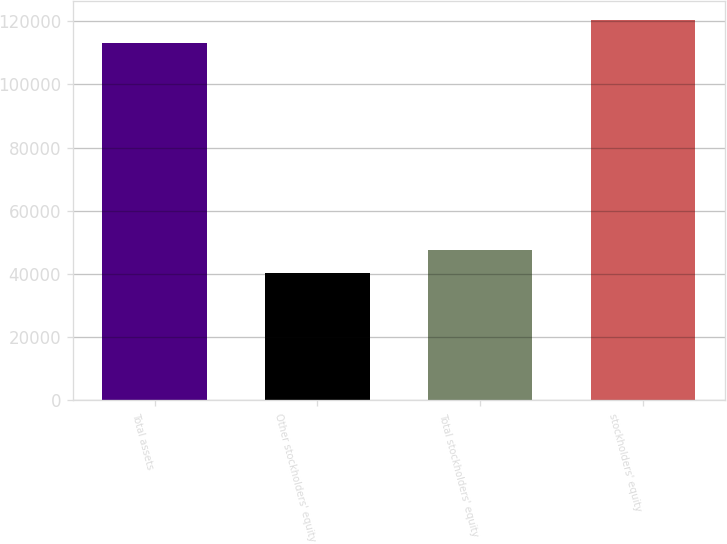Convert chart. <chart><loc_0><loc_0><loc_500><loc_500><bar_chart><fcel>Total assets<fcel>Other stockholders' equity<fcel>Total stockholders' equity<fcel>stockholders' equity<nl><fcel>113017<fcel>40417<fcel>47677<fcel>120277<nl></chart> 